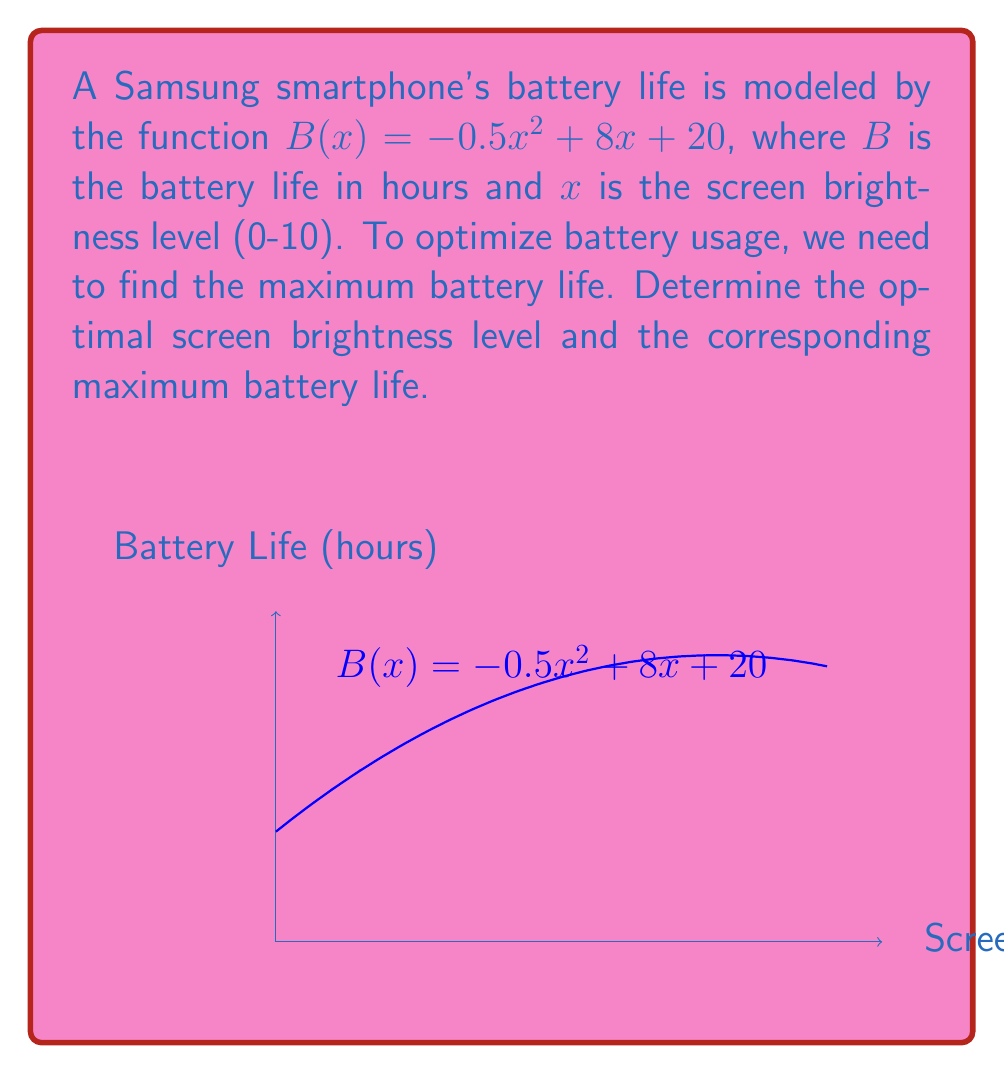Can you solve this math problem? To find the maximum battery life, we need to find the vertex of the parabola described by $B(x)$. The steps are as follows:

1) The general form of a quadratic function is $f(x) = ax^2 + bx + c$. In this case:
   $a = -0.5$, $b = 8$, and $c = 20$

2) For a quadratic function, the x-coordinate of the vertex is given by $x = -\frac{b}{2a}$

3) Substituting our values:
   $x = -\frac{8}{2(-0.5)} = -\frac{8}{-1} = 8$

4) To find the maximum battery life, we substitute $x = 8$ into the original function:
   $B(8) = -0.5(8)^2 + 8(8) + 20$
         $= -0.5(64) + 64 + 20$
         $= -32 + 64 + 20$
         $= 52$

Therefore, the optimal screen brightness level is 8, and the maximum battery life is 52 hours.
Answer: Optimal brightness: 8; Maximum battery life: 52 hours 